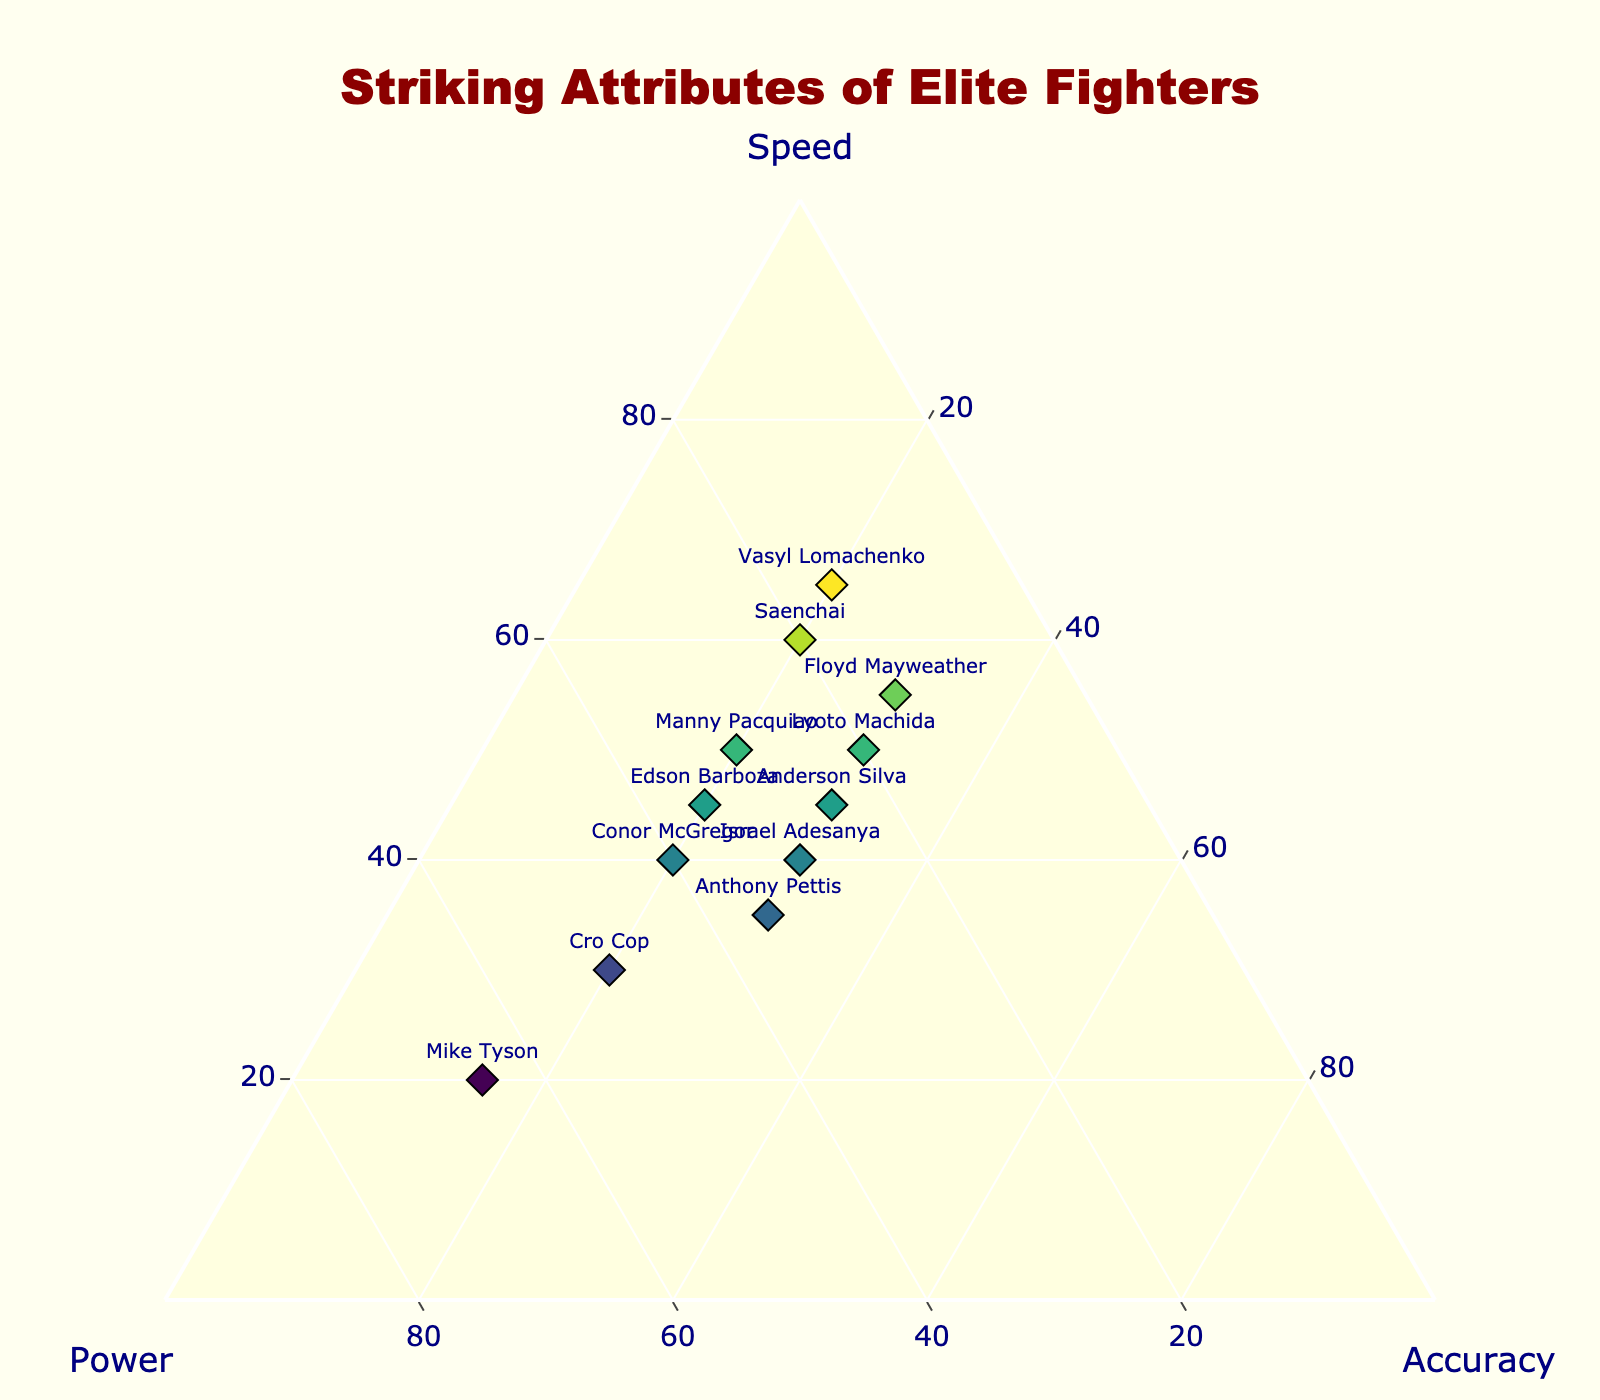What's the title of the figure? The title is often clearly shown at the top of the chart. In this case, the title is prominently styled in dark red font.
Answer: Striking Attributes of Elite Fighters How many fighters have Speed as their highest attribute? To determine this, look for points closest to the 'Speed' vertex of the triangle (topmost point). Count the fighters plotted near this vertex.
Answer: 4 Which fighter shows the highest Speed attribute? Identify the fighter whose marker is closest to the 'Speed' vertex, which would be at the top of the ternary plot.
Answer: Vasyl Lomachenko Who are the fighters with the same values for Speed and Power? Look for markers equidistant from the 'Speed' and 'Power' vertices. These fighters will be positioned along the line bisecting the angle between Speed and Power.
Answer: Conor McGregor, Anthony Pettis Compare the Speed and Accuracy attributes of Mike Tyson and Manny Pacquiao. Which fighter has higher values in both attributes? Analyze the plot to find Mike Tyson and Manny Pacquiao. Compare their positions relative to the Speed and Accuracy vertices. Mike Tyson is closer to the Power corner, so compare the relative distances of each fighter's marker from the Speed and Accuracy vertices.
Answer: Manny Pacquiao What is the total percentage combination of all attributes for Floyd Mayweather? Given each ternary plot point sums up to 100%, add the values of Speed, Power, and Accuracy for Floyd Mayweather.
Answer: 100% Who has the lowest contribution from the Accuracy attribute? Focus on the points closest to the 'Power' and 'Speed' vertices (bottom left and right respectively) and the furthest from the 'Accuracy' vertex.
Answer: Mike Tyson Which fighter has equal contributions from Speed, Power, and Accuracy? Look for any fighter’s marker positioned at the exact center of the ternary plot where all three attributes would equally contribute.
Answer: None What is the average Speed value for all the fighters? Sum the Speed values of all fighters and divide by the number of fighters. (40 + 45 + 55 + 20 + 50 + 60 + 35 + 45 + 30 + 40 + 50 + 65) / 12 = 475 / 12
Answer: ~39.58 Between Cro Cop and Israel Adesanya, who has a higher Accuracy attribute? Compare the positions of the markers labeled 'Cro Cop' and 'Israel Adesanya' relative to the Accuracy vertex.
Answer: Israel Adesanya 